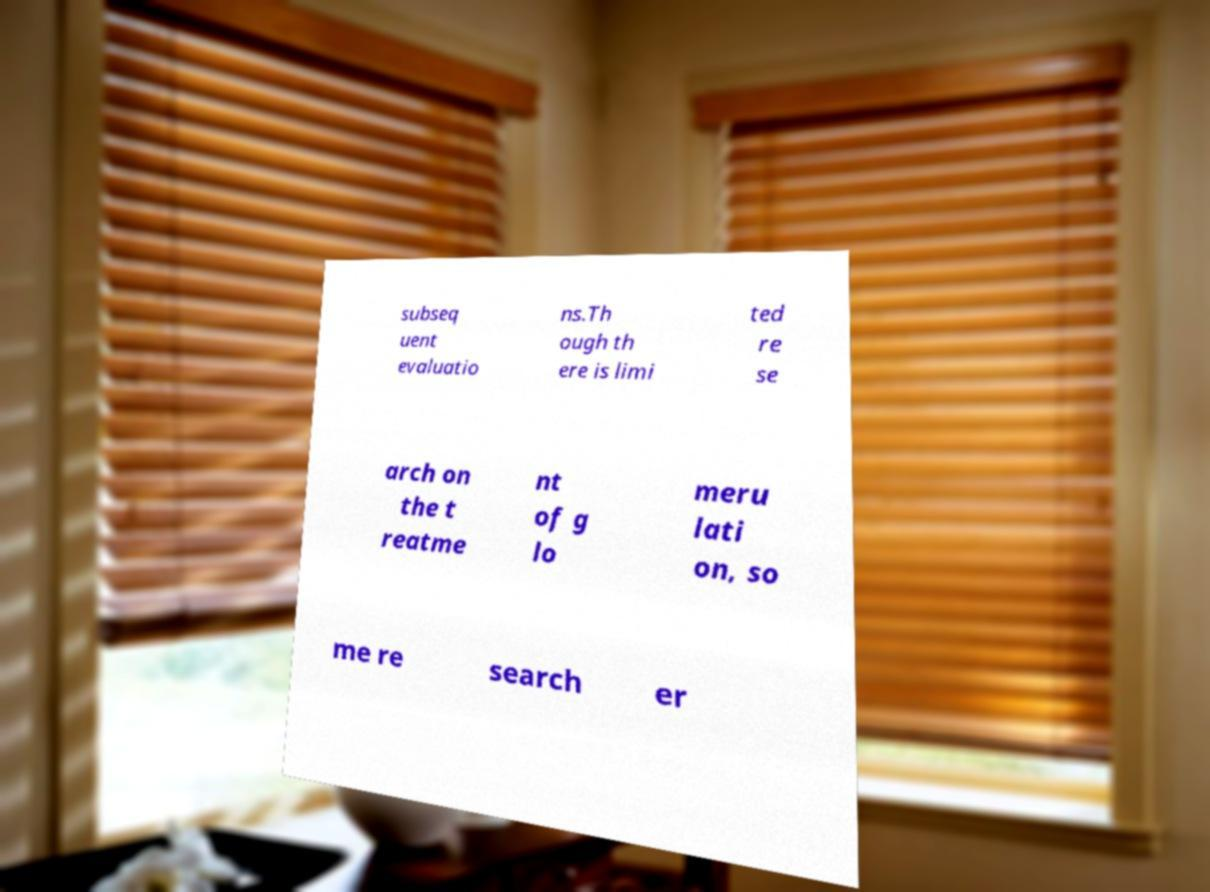For documentation purposes, I need the text within this image transcribed. Could you provide that? subseq uent evaluatio ns.Th ough th ere is limi ted re se arch on the t reatme nt of g lo meru lati on, so me re search er 